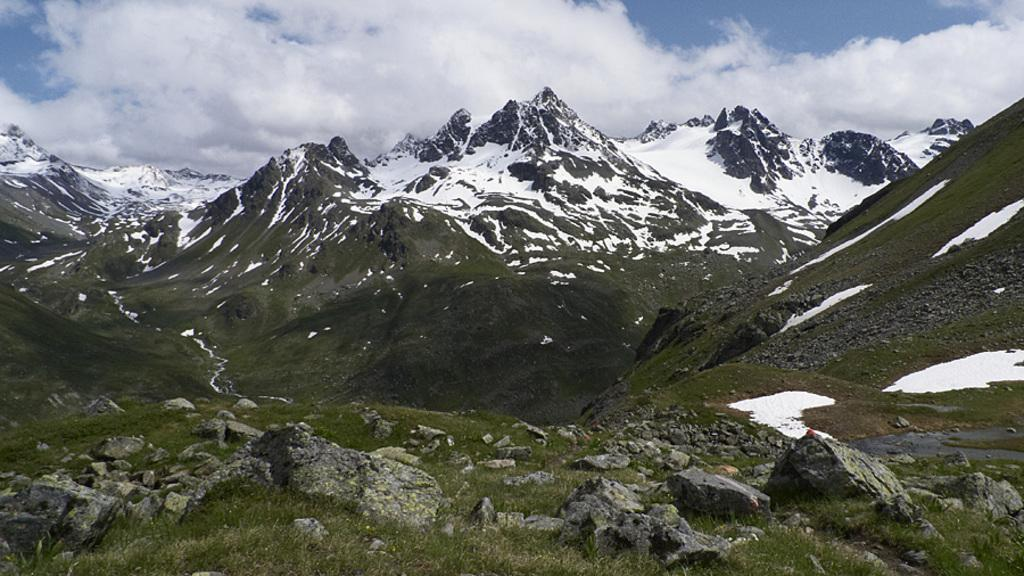What type of terrain is visible at the bottom of the image? There are rocks at the bottom of the image. What type of vegetation is present in the image? There is grass in the image. What type of landscape can be seen in the background of the image? There are mountains in the background of the image. What is visible at the top of the image? The sky is visible at the top of the image. How many beginner shoes are visible in the image? There are no shoes present in the image. What type of ticket can be seen in the image? There are no tickets present in the image. 